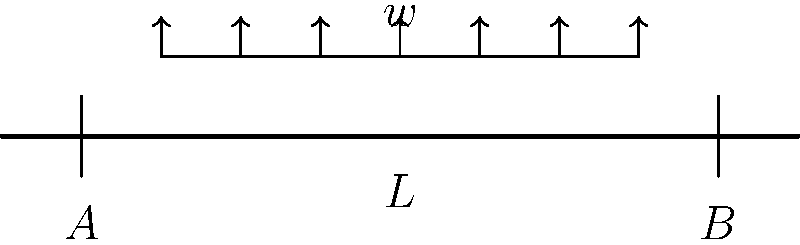As a voice actor known for your character impressions, imagine you're narrating a documentary about engineering marvels. Describe the stress distribution in the simply supported beam shown above, subjected to a uniformly distributed load $w$. What is the maximum bending moment $M_{max}$ in terms of $w$ and $L$? Let's analyze this step-by-step:

1) First, we need to determine the reaction forces at the supports A and B. Due to symmetry, each support will bear half of the total load.

   $R_A = R_B = \frac{wL}{2}$

2) The bending moment at any point $x$ along the beam is given by:

   $M(x) = R_A \cdot x - w \cdot x \cdot \frac{x}{2}$

3) Substituting $R_A = \frac{wL}{2}$:

   $M(x) = \frac{wL}{2} \cdot x - \frac{wx^2}{2}$

4) To find the maximum bending moment, we need to find where $\frac{dM}{dx} = 0$:

   $\frac{dM}{dx} = \frac{wL}{2} - wx = 0$

5) Solving this equation:

   $x = \frac{L}{2}$

6) The maximum bending moment occurs at the center of the beam $(x = \frac{L}{2})$. Substituting this back into the moment equation:

   $M_{max} = M(\frac{L}{2}) = \frac{wL}{2} \cdot \frac{L}{2} - \frac{w(\frac{L}{2})^2}{2}$

7) Simplifying:

   $M_{max} = \frac{wL^2}{8}$

Thus, the maximum bending moment occurs at the center of the beam and is equal to $\frac{wL^2}{8}$.
Answer: $M_{max} = \frac{wL^2}{8}$ 